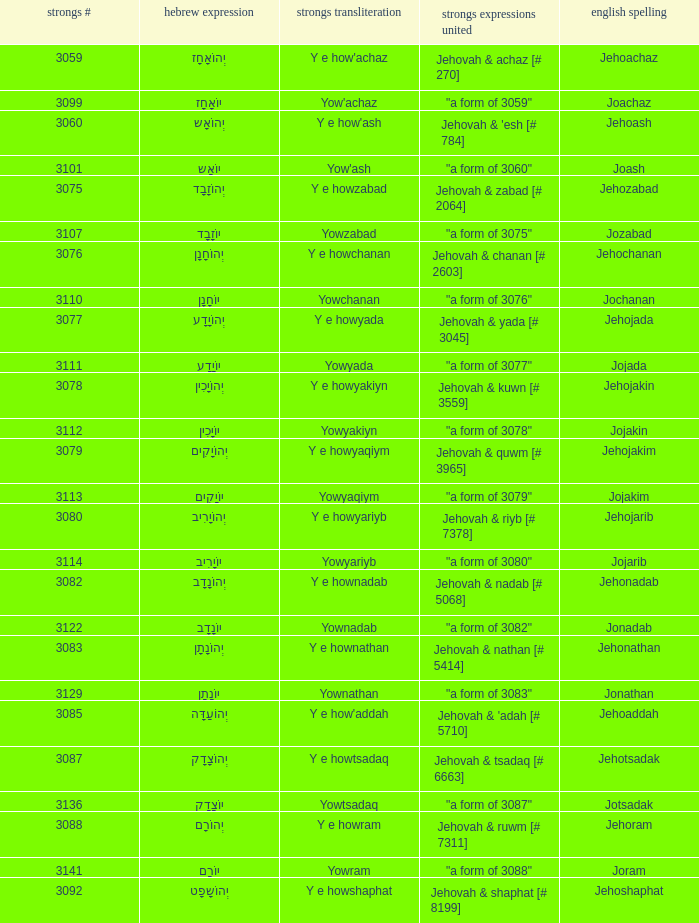What is the strong words compounded when the strongs transliteration is yowyariyb? "a form of 3080". 